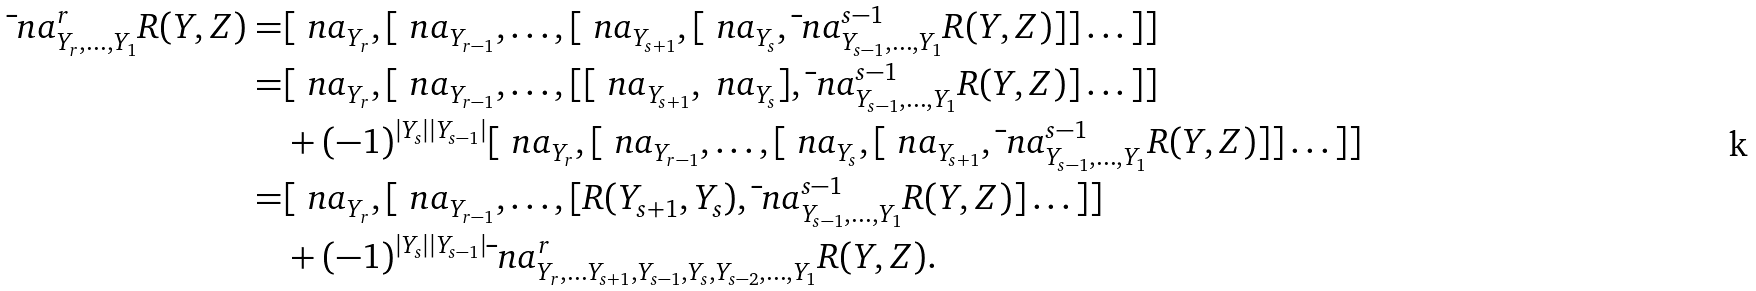Convert formula to latex. <formula><loc_0><loc_0><loc_500><loc_500>\bar { \ } n a ^ { r } _ { Y _ { r } , \dots , Y _ { 1 } } R ( Y , Z ) = & [ \ n a _ { Y _ { r } } , [ \ n a _ { Y _ { r - 1 } } , \dots , [ \ n a _ { Y _ { s + 1 } } , [ \ n a _ { Y _ { s } } , \bar { \ } n a ^ { s - 1 } _ { Y _ { s - 1 } , \dots , Y _ { 1 } } R ( Y , Z ) ] ] \dots ] ] \\ = & [ \ n a _ { Y _ { r } } , [ \ n a _ { Y _ { r - 1 } } , \dots , [ [ \ n a _ { Y _ { s + 1 } } , \ n a _ { Y _ { s } } ] , \bar { \ } n a ^ { s - 1 } _ { Y _ { s - 1 } , \dots , Y _ { 1 } } R ( Y , Z ) ] \dots ] ] \\ & + ( - 1 ) ^ { | Y _ { s } | | Y _ { s - 1 } | } [ \ n a _ { Y _ { r } } , [ \ n a _ { Y _ { r - 1 } } , \dots , [ \ n a _ { Y _ { s } } , [ \ n a _ { Y _ { s + 1 } } , \bar { \ } n a ^ { s - 1 } _ { Y _ { s - 1 } , \dots , Y _ { 1 } } R ( Y , Z ) ] ] \dots ] ] \\ = & [ \ n a _ { Y _ { r } } , [ \ n a _ { Y _ { r - 1 } } , \dots , [ R ( { Y _ { s + 1 } } , { Y _ { s } } ) , \bar { \ } n a ^ { s - 1 } _ { Y _ { s - 1 } , \dots , Y _ { 1 } } R ( Y , Z ) ] \dots ] ] \\ & + ( - 1 ) ^ { | Y _ { s } | | Y _ { s - 1 } | } \bar { \ } n a ^ { r } _ { Y _ { r } , \dots Y _ { s + 1 } , Y _ { s - 1 } , Y _ { s } , Y _ { s - 2 } , \dots , Y _ { 1 } } R ( Y , Z ) .</formula> 